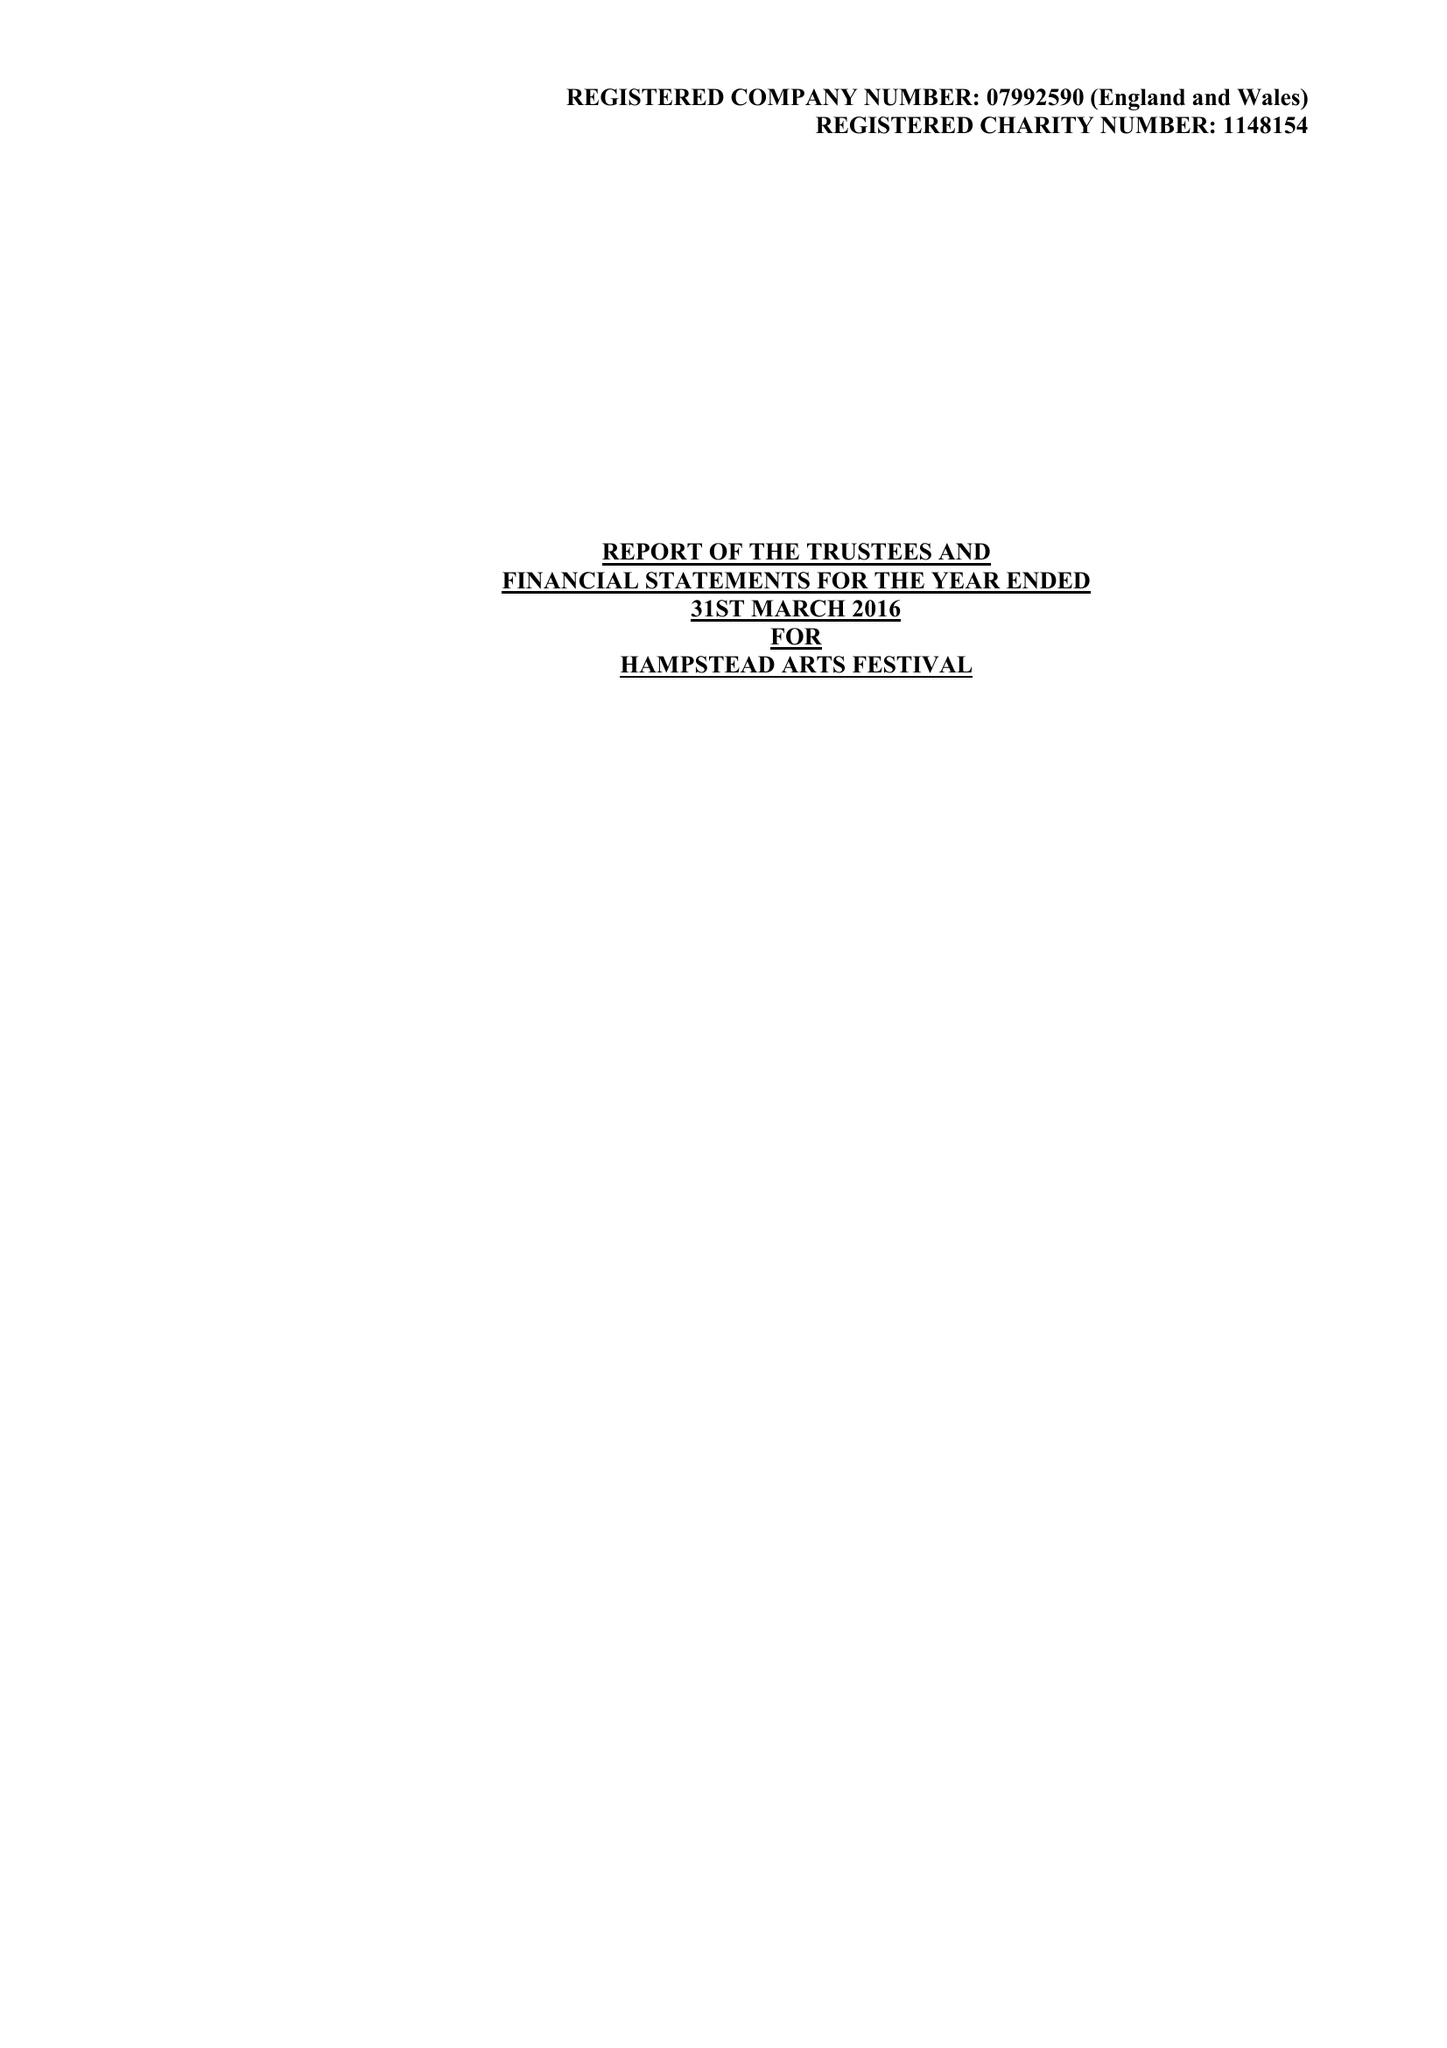What is the value for the address__post_town?
Answer the question using a single word or phrase. HARROW 